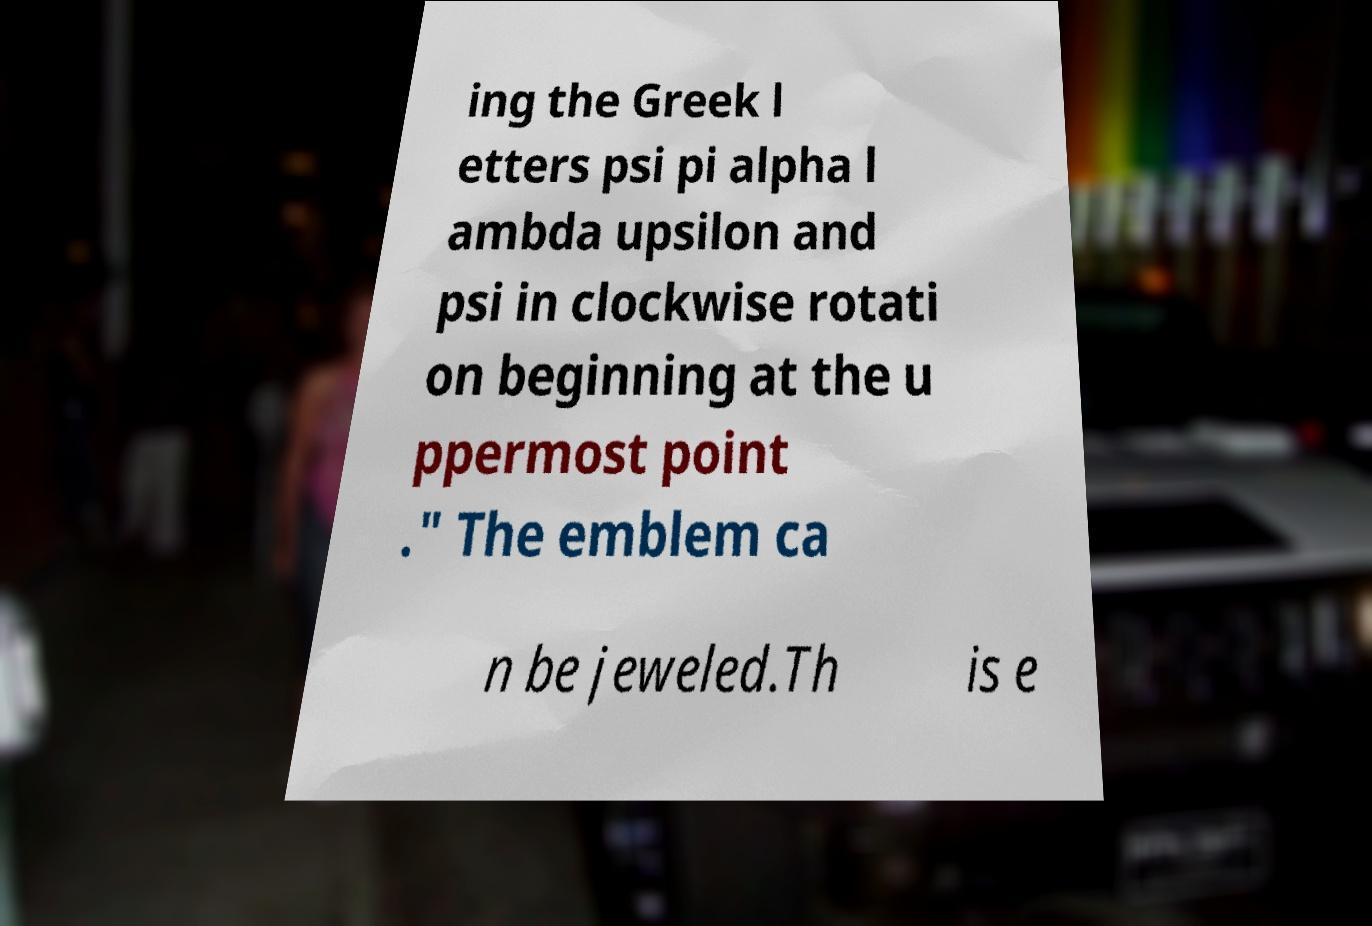For documentation purposes, I need the text within this image transcribed. Could you provide that? ing the Greek l etters psi pi alpha l ambda upsilon and psi in clockwise rotati on beginning at the u ppermost point ." The emblem ca n be jeweled.Th is e 